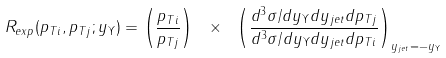<formula> <loc_0><loc_0><loc_500><loc_500>R _ { e x p } ( p _ { T i } , p _ { T j } ; y _ { \Upsilon } ) = \left ( \frac { p _ { T i } } { p _ { T j } } \right ) \ { \times } \ \left ( \frac { d ^ { 3 } { \sigma } / d y _ { \Upsilon } d y _ { j e t } d p _ { T j } } { d ^ { 3 } { \sigma } / d y _ { \Upsilon } d y _ { j e t } d p _ { T i } } \right ) _ { y _ { j e t } = - y _ { \Upsilon } }</formula> 